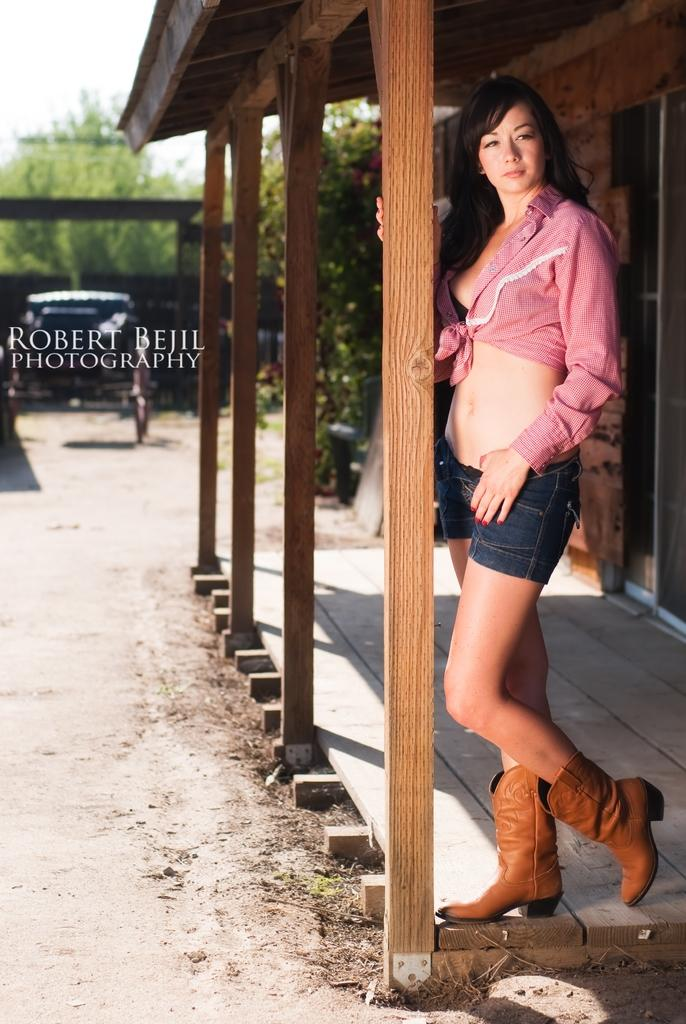What is the person in the image wearing? The person is wearing a pink top and jeans. What can be seen in the background of the image? There is a house, trees, a vehicle, and a shed in the background. What is the color of the sky in the image? The sky is white in color. Can you see a zephyr blowing through the trees in the image? There is no mention of a zephyr in the image, and it is not visible. 